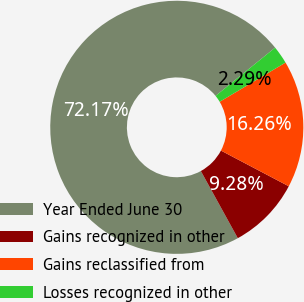<chart> <loc_0><loc_0><loc_500><loc_500><pie_chart><fcel>Year Ended June 30<fcel>Gains recognized in other<fcel>Gains reclassified from<fcel>Losses recognized in other<nl><fcel>72.17%<fcel>9.28%<fcel>16.26%<fcel>2.29%<nl></chart> 